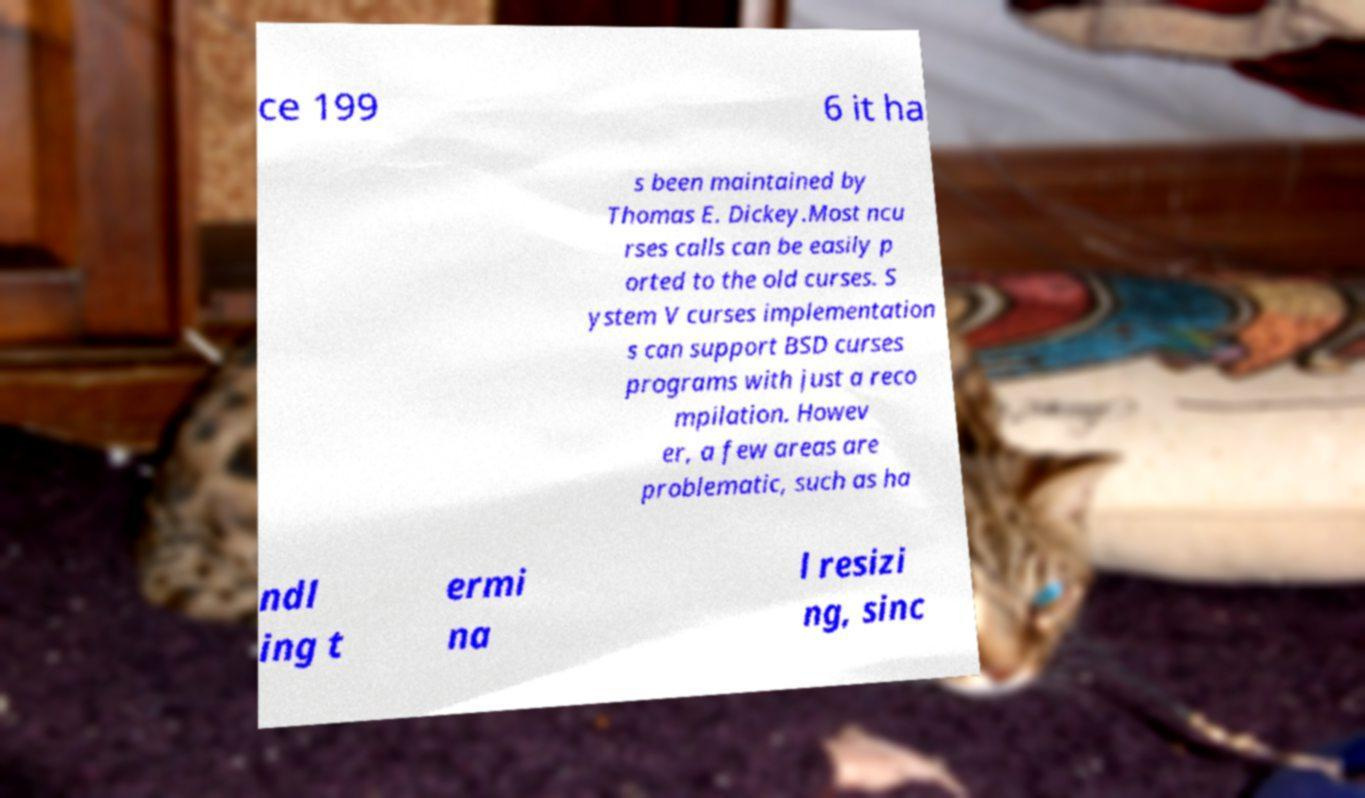I need the written content from this picture converted into text. Can you do that? ce 199 6 it ha s been maintained by Thomas E. Dickey.Most ncu rses calls can be easily p orted to the old curses. S ystem V curses implementation s can support BSD curses programs with just a reco mpilation. Howev er, a few areas are problematic, such as ha ndl ing t ermi na l resizi ng, sinc 